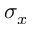Convert formula to latex. <formula><loc_0><loc_0><loc_500><loc_500>\sigma _ { x }</formula> 